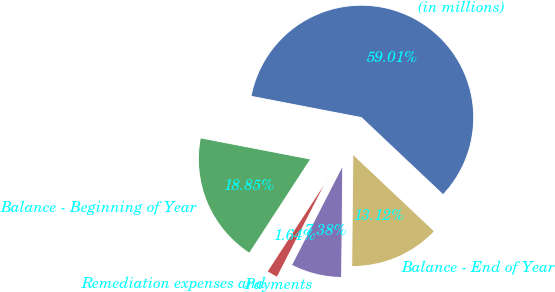Convert chart. <chart><loc_0><loc_0><loc_500><loc_500><pie_chart><fcel>(in millions)<fcel>Balance - Beginning of Year<fcel>Remediation expenses and<fcel>Payments<fcel>Balance - End of Year<nl><fcel>59.01%<fcel>18.85%<fcel>1.64%<fcel>7.38%<fcel>13.12%<nl></chart> 